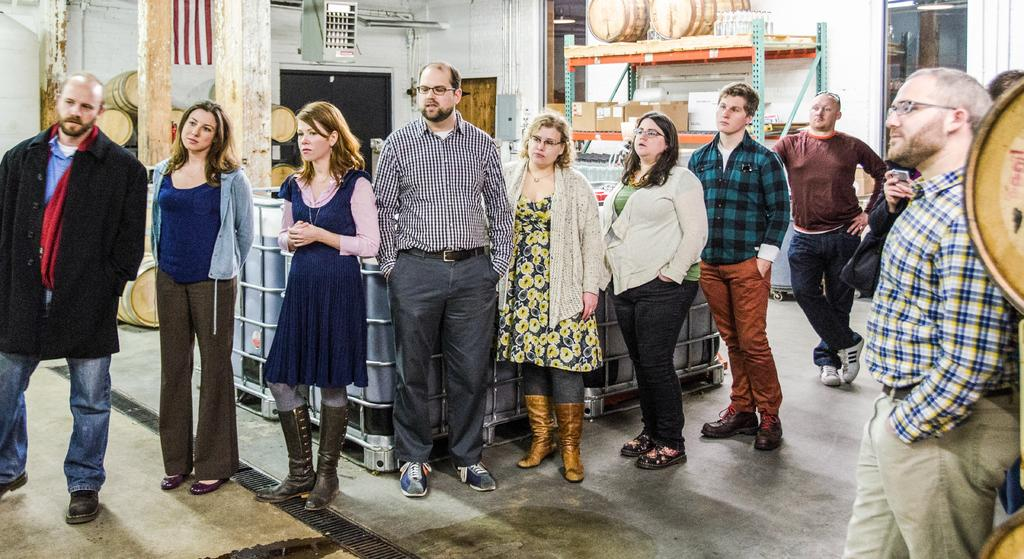What is the main subject of the image? The main subject of the image is a group of people standing. What objects can be seen in the image besides the people? There are barrels, pallet containers, cardboard boxes, lights, a rack, and a wall visible in the image. Can you describe the setting or environment in the image? The image appears to be set in a warehouse or storage area, with various containers and boxes present. Can you hear the bee buzzing in the image? There is no bee present in the image, so it cannot be heard buzzing. 